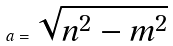Convert formula to latex. <formula><loc_0><loc_0><loc_500><loc_500>a = \sqrt { n ^ { 2 } - m ^ { 2 } }</formula> 